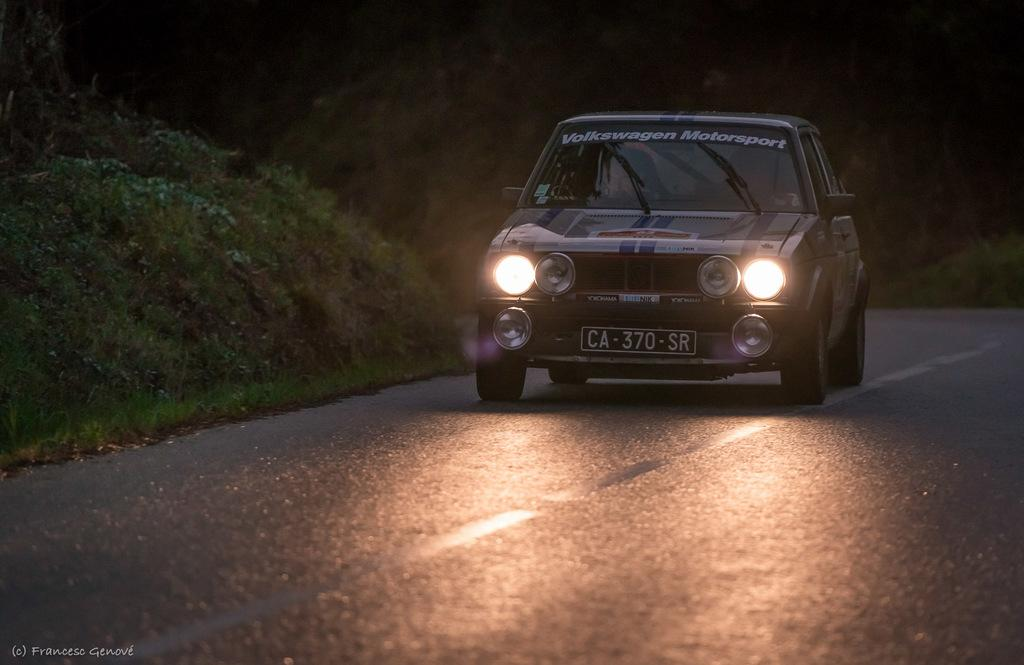What is the main subject of the image? The main subject of the image is a vehicle with a number plate. Where is the vehicle located in the image? The vehicle is on the road in the image. What type of vegetation can be seen in the image? There is some grass visible in the image. How would you describe the lighting in the image? The background of the image is dark. What color is the brain of the person driving the vehicle in the image? There is no information about the driver or their brain in the image, so we cannot determine the color of the brain. 